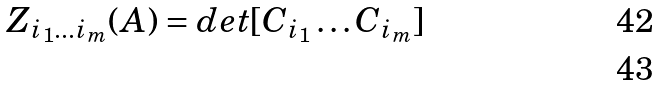Convert formula to latex. <formula><loc_0><loc_0><loc_500><loc_500>Z _ { i _ { 1 } \dots i _ { m } } ( A ) = d e t [ C _ { i _ { 1 } } \dots C _ { i _ { m } } ] \\</formula> 